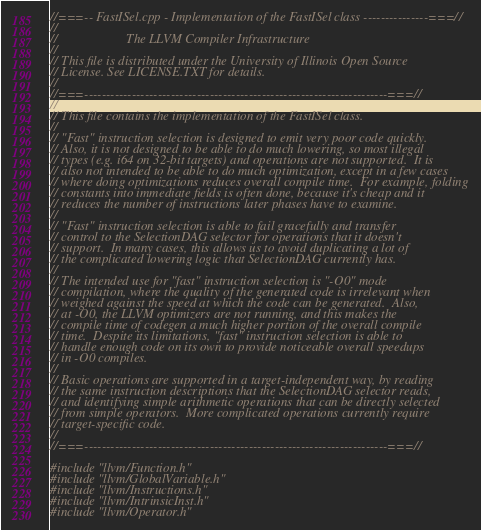Convert code to text. <code><loc_0><loc_0><loc_500><loc_500><_C++_>//===-- FastISel.cpp - Implementation of the FastISel class ---------------===//
//
//                     The LLVM Compiler Infrastructure
//
// This file is distributed under the University of Illinois Open Source
// License. See LICENSE.TXT for details.
//
//===----------------------------------------------------------------------===//
//
// This file contains the implementation of the FastISel class.
//
// "Fast" instruction selection is designed to emit very poor code quickly.
// Also, it is not designed to be able to do much lowering, so most illegal
// types (e.g. i64 on 32-bit targets) and operations are not supported.  It is
// also not intended to be able to do much optimization, except in a few cases
// where doing optimizations reduces overall compile time.  For example, folding
// constants into immediate fields is often done, because it's cheap and it
// reduces the number of instructions later phases have to examine.
//
// "Fast" instruction selection is able to fail gracefully and transfer
// control to the SelectionDAG selector for operations that it doesn't
// support.  In many cases, this allows us to avoid duplicating a lot of
// the complicated lowering logic that SelectionDAG currently has.
//
// The intended use for "fast" instruction selection is "-O0" mode
// compilation, where the quality of the generated code is irrelevant when
// weighed against the speed at which the code can be generated.  Also,
// at -O0, the LLVM optimizers are not running, and this makes the
// compile time of codegen a much higher portion of the overall compile
// time.  Despite its limitations, "fast" instruction selection is able to
// handle enough code on its own to provide noticeable overall speedups
// in -O0 compiles.
//
// Basic operations are supported in a target-independent way, by reading
// the same instruction descriptions that the SelectionDAG selector reads,
// and identifying simple arithmetic operations that can be directly selected
// from simple operators.  More complicated operations currently require
// target-specific code.
//
//===----------------------------------------------------------------------===//

#include "llvm/Function.h"
#include "llvm/GlobalVariable.h"
#include "llvm/Instructions.h"
#include "llvm/IntrinsicInst.h"
#include "llvm/Operator.h"</code> 